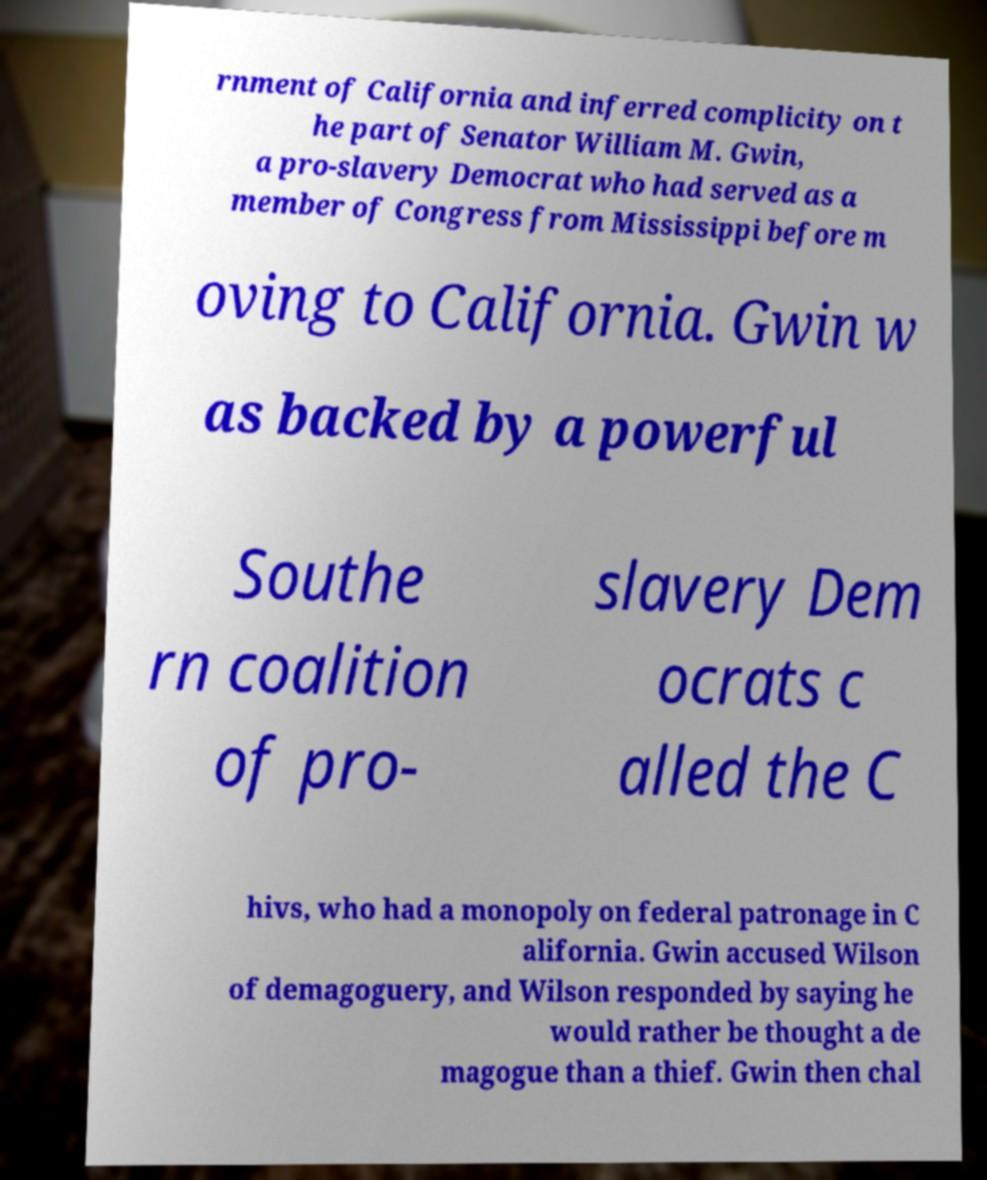Can you read and provide the text displayed in the image?This photo seems to have some interesting text. Can you extract and type it out for me? rnment of California and inferred complicity on t he part of Senator William M. Gwin, a pro-slavery Democrat who had served as a member of Congress from Mississippi before m oving to California. Gwin w as backed by a powerful Southe rn coalition of pro- slavery Dem ocrats c alled the C hivs, who had a monopoly on federal patronage in C alifornia. Gwin accused Wilson of demagoguery, and Wilson responded by saying he would rather be thought a de magogue than a thief. Gwin then chal 